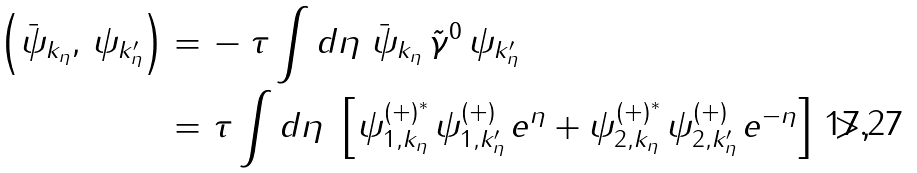<formula> <loc_0><loc_0><loc_500><loc_500>\left ( \bar { \psi } _ { k _ { \eta } } , \, \psi _ { k _ { \eta } ^ { \prime } } \right ) = & \, - \tau \int d \eta \ \bar { \psi } _ { k _ { \eta } } \, \tilde { \gamma } ^ { 0 } \, \psi _ { k _ { \eta } ^ { \prime } } \\ = & \ \tau \int d \eta \ \left [ \psi ^ { ( + ) ^ { * } } _ { 1 , k _ { \eta } } \, \psi ^ { ( + ) } _ { 1 , k _ { \eta } ^ { \prime } } \, e ^ { \eta } + \psi ^ { ( + ) ^ { * } } _ { 2 , k _ { \eta } } \, \psi ^ { ( + ) } _ { 2 , k _ { \eta } ^ { \prime } } \, e ^ { - \eta } \right ] \ > ,</formula> 